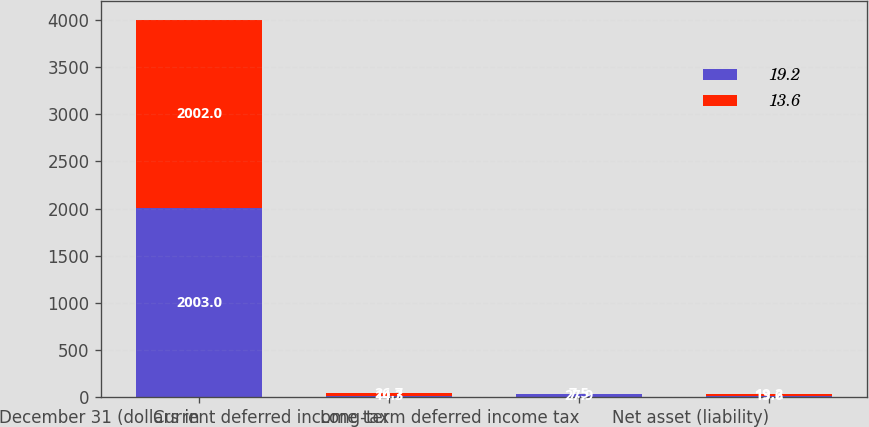Convert chart. <chart><loc_0><loc_0><loc_500><loc_500><stacked_bar_chart><ecel><fcel>December 31 (dollars in<fcel>Current deferred income tax<fcel>Long-term deferred income tax<fcel>Net asset (liability)<nl><fcel>19.2<fcel>2003<fcel>14.3<fcel>27.9<fcel>13.6<nl><fcel>13.6<fcel>2002<fcel>26.7<fcel>7.5<fcel>19.2<nl></chart> 